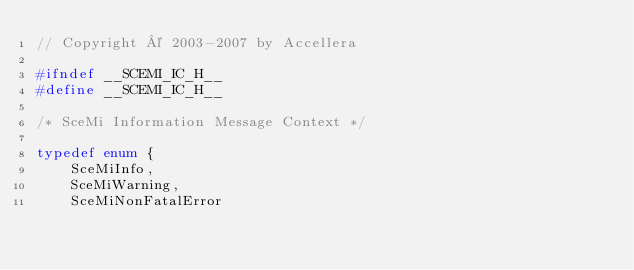<code> <loc_0><loc_0><loc_500><loc_500><_C_>// Copyright © 2003-2007 by Accellera

#ifndef __SCEMI_IC_H__
#define __SCEMI_IC_H__

/* SceMi Information Message Context */

typedef enum {
    SceMiInfo,
    SceMiWarning,
    SceMiNonFatalError</code> 